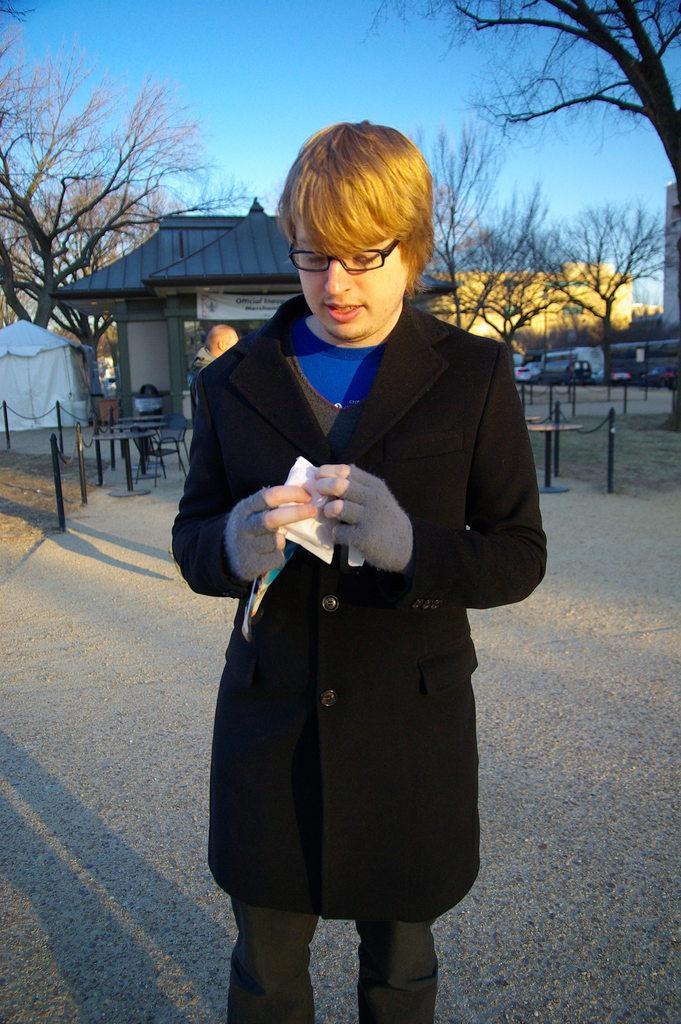How would you summarize this image in a sentence or two? In this image we can see a man wearing a black jacket and spectacles is holding something in his hands and standing here. In the background, we can see the house, fence, hut, trees and the blue color sky. 